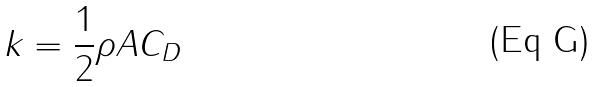<formula> <loc_0><loc_0><loc_500><loc_500>k = \frac { 1 } { 2 } \rho A C _ { D }</formula> 